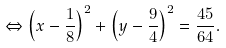Convert formula to latex. <formula><loc_0><loc_0><loc_500><loc_500>\Leftrightarrow \left ( x - { \frac { 1 } { 8 } } \right ) ^ { 2 } + \left ( y - { \frac { 9 } { 4 } } \right ) ^ { 2 } = { \frac { 4 5 } { 6 4 } } .</formula> 